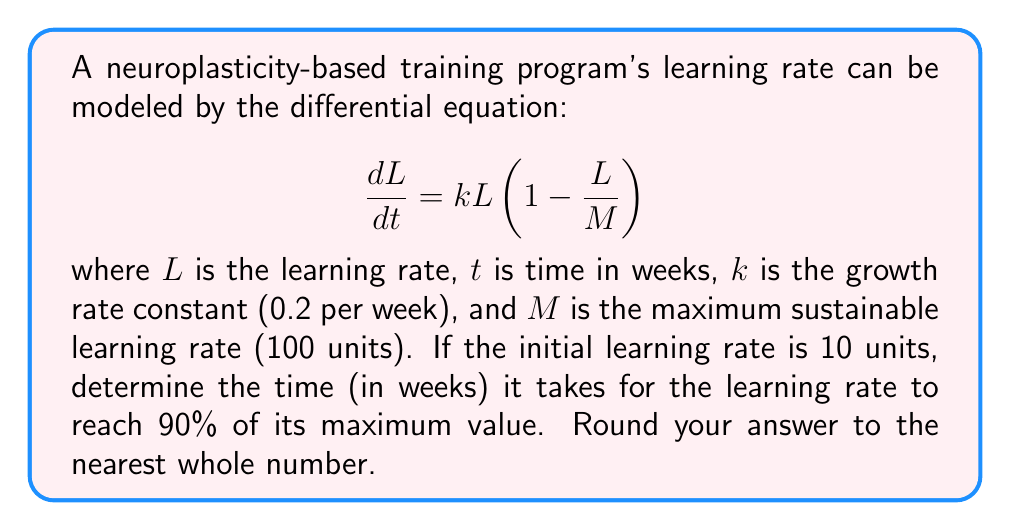Provide a solution to this math problem. To solve this problem, we need to follow these steps:

1) First, we recognize this as a logistic growth model. The solution to this differential equation is:

   $$ L(t) = \frac{M}{1 + (\frac{M}{L_0} - 1)e^{-kt}} $$

   where $L_0$ is the initial learning rate.

2) We're given:
   $M = 100$, $k = 0.2$, $L_0 = 10$

3) We want to find $t$ when $L(t) = 0.9M = 90$

4) Substituting these values into the equation:

   $$ 90 = \frac{100}{1 + (\frac{100}{10} - 1)e^{-0.2t}} $$

5) Simplifying:

   $$ 90 = \frac{100}{1 + 9e^{-0.2t}} $$

6) Multiply both sides by $(1 + 9e^{-0.2t})$:

   $$ 90(1 + 9e^{-0.2t}) = 100 $$

7) Expand:

   $$ 90 + 810e^{-0.2t} = 100 $$

8) Subtract 90 from both sides:

   $$ 810e^{-0.2t} = 10 $$

9) Divide both sides by 810:

   $$ e^{-0.2t} = \frac{1}{81} $$

10) Take natural log of both sides:

    $$ -0.2t = \ln(\frac{1}{81}) = -\ln(81) $$

11) Divide both sides by -0.2:

    $$ t = \frac{\ln(81)}{0.2} \approx 21.9 $$

12) Rounding to the nearest whole number:

    $$ t \approx 22 $$
Answer: 22 weeks 